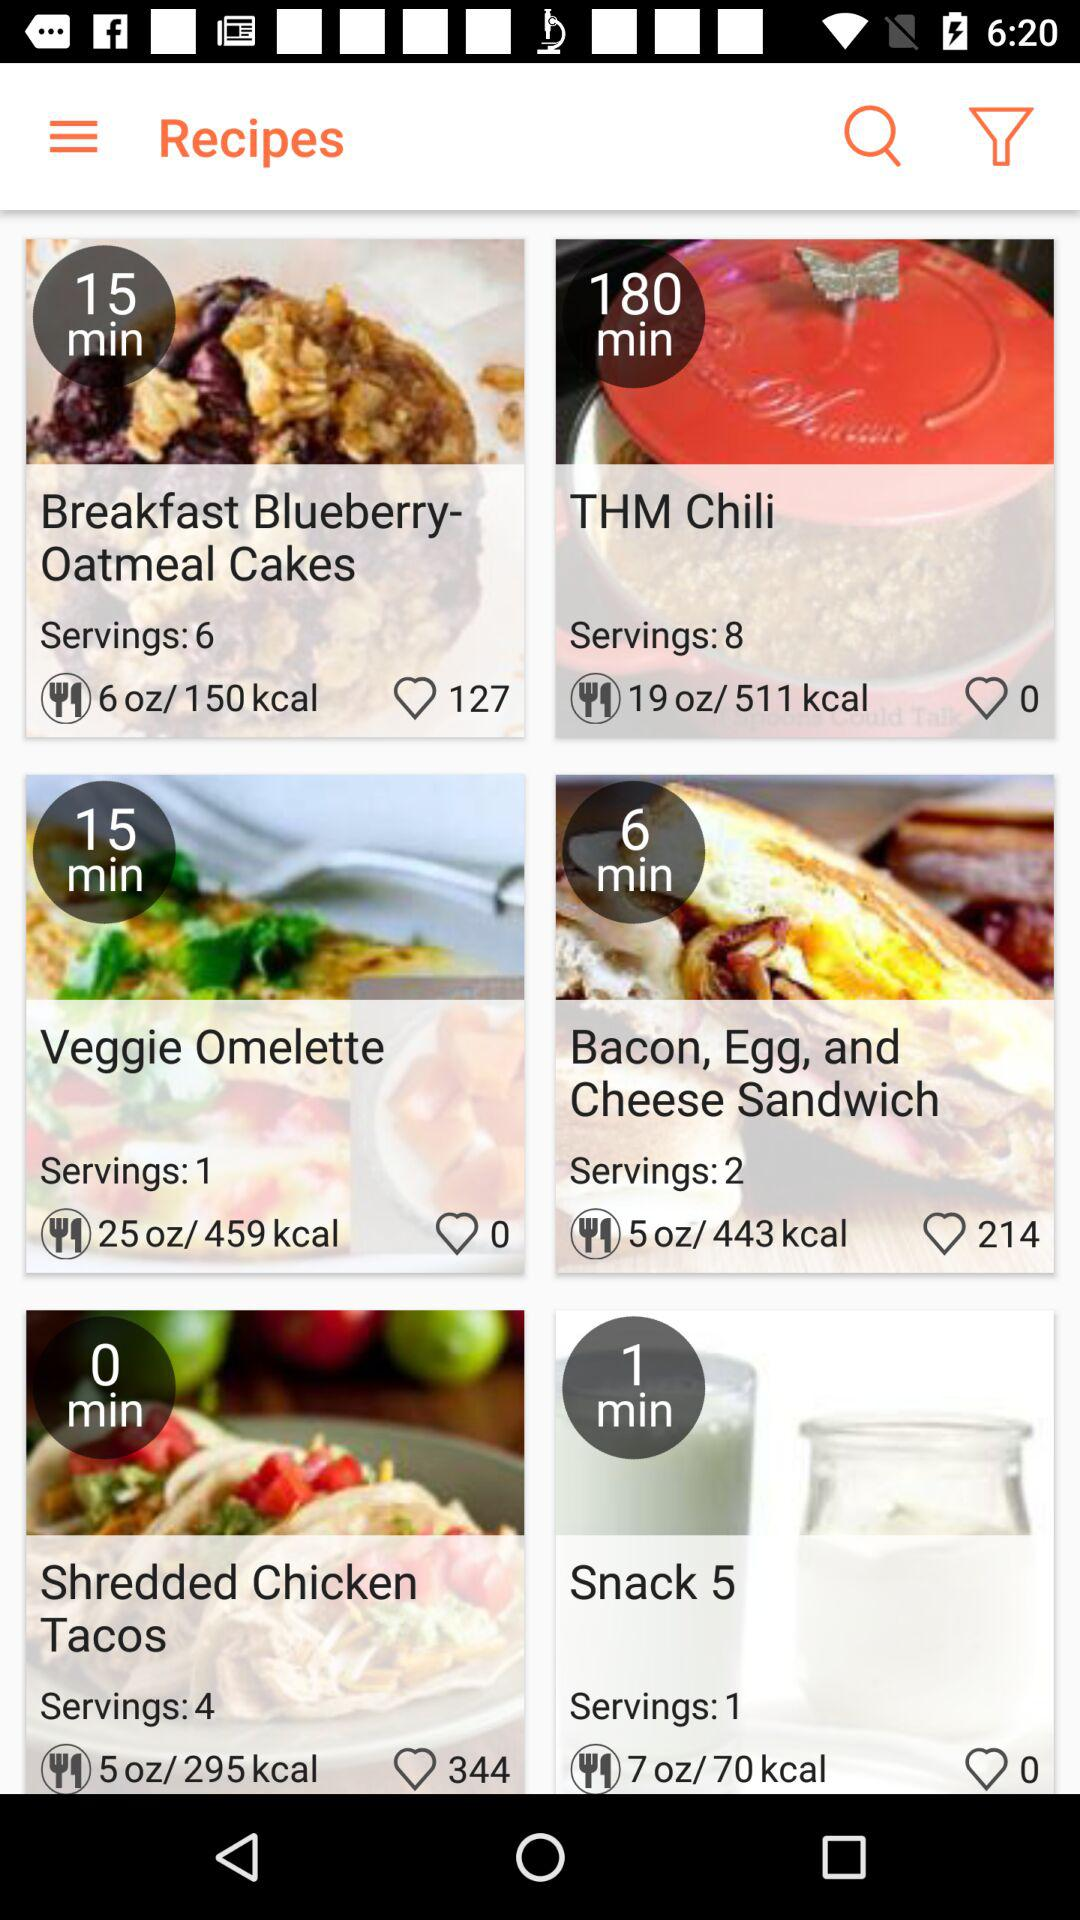What is the calorie count for "THM Chili"? The calorie count is 511. 